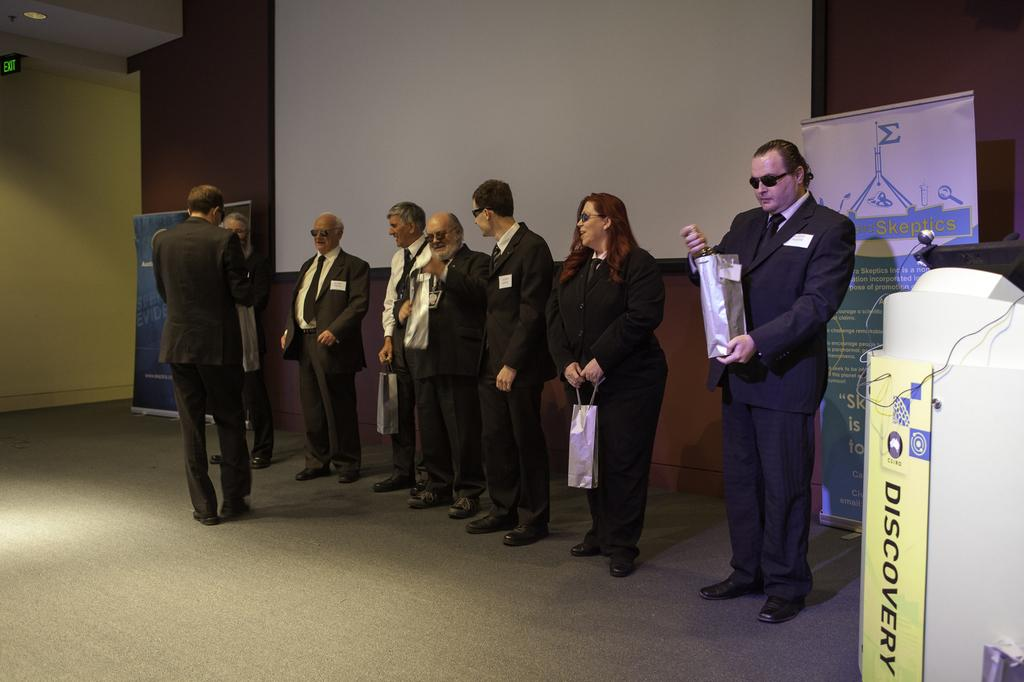What is happening in the image involving people? There are people standing in the image. What can be seen on the right side of the image? There is a podium on the right side of the image. What is featured in the image besides people? There is a poster in the image. What color is the wall in the image? The wall in the image is yellow. How many frogs are jumping on the moon in the image? There are no frogs or moons present in the image. 